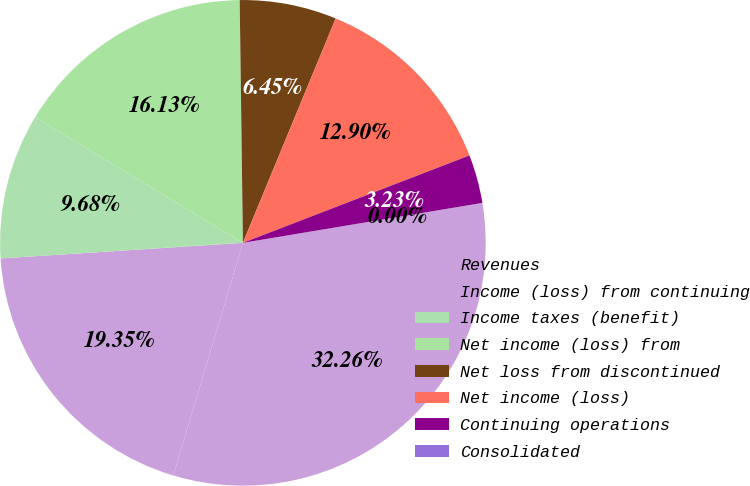Convert chart to OTSL. <chart><loc_0><loc_0><loc_500><loc_500><pie_chart><fcel>Revenues<fcel>Income (loss) from continuing<fcel>Income taxes (benefit)<fcel>Net income (loss) from<fcel>Net loss from discontinued<fcel>Net income (loss)<fcel>Continuing operations<fcel>Consolidated<nl><fcel>32.26%<fcel>19.35%<fcel>9.68%<fcel>16.13%<fcel>6.45%<fcel>12.9%<fcel>3.23%<fcel>0.0%<nl></chart> 